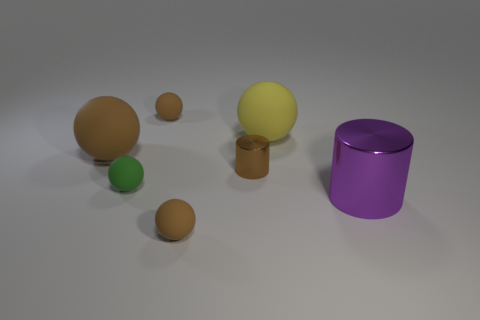Are there more tiny brown spheres that are behind the big purple thing than tiny cylinders that are behind the small metal object?
Keep it short and to the point. Yes. How many cylinders are large red matte things or brown matte objects?
Offer a very short reply. 0. How many objects are small brown matte balls in front of the small metallic cylinder or brown cubes?
Make the answer very short. 1. There is a big object that is to the left of the large matte ball that is right of the shiny thing left of the purple object; what shape is it?
Keep it short and to the point. Sphere. What number of other large matte objects are the same shape as the yellow thing?
Give a very brief answer. 1. There is a big sphere that is the same color as the tiny cylinder; what is its material?
Your answer should be very brief. Rubber. Is the large brown object made of the same material as the purple thing?
Your answer should be very brief. No. There is a small object on the right side of the tiny brown thing in front of the brown metallic cylinder; how many green spheres are left of it?
Your answer should be compact. 1. Are there any cylinders that have the same material as the yellow ball?
Your answer should be very brief. No. Are there fewer small red matte spheres than large objects?
Your answer should be compact. Yes. 